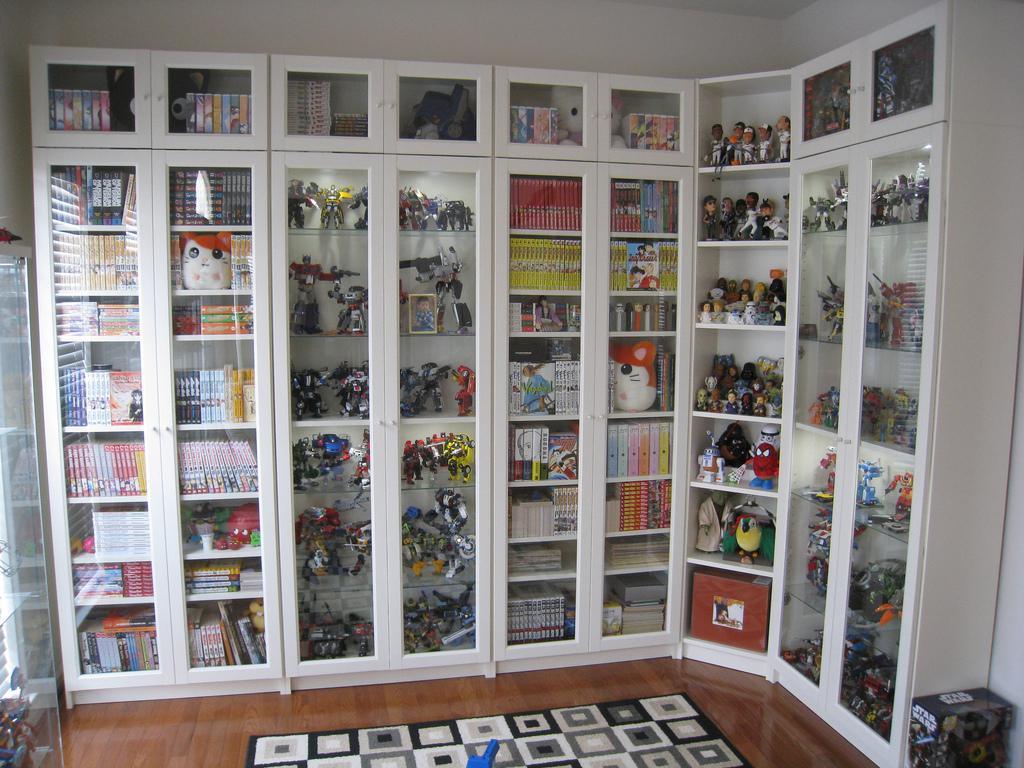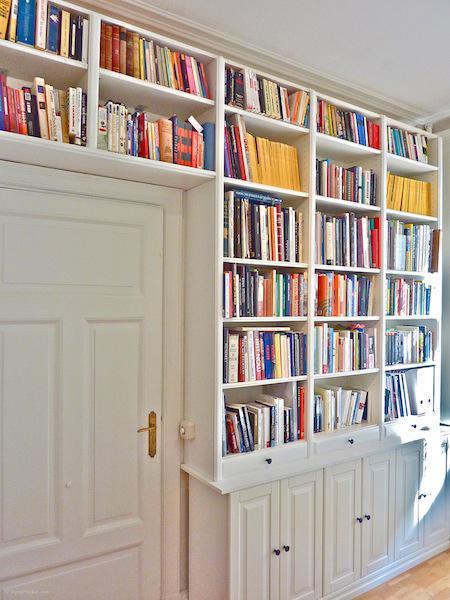The first image is the image on the left, the second image is the image on the right. Evaluate the accuracy of this statement regarding the images: "In one image, a floor to ceiling white shelving unit is curved around the corner of a room.". Is it true? Answer yes or no. Yes. 